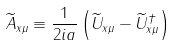<formula> <loc_0><loc_0><loc_500><loc_500>\widetilde { A } _ { x \mu } \equiv \frac { 1 } { 2 i a } \left ( \widetilde { U } _ { x \mu } - \widetilde { U } ^ { \dagger } _ { x \mu } \right )</formula> 